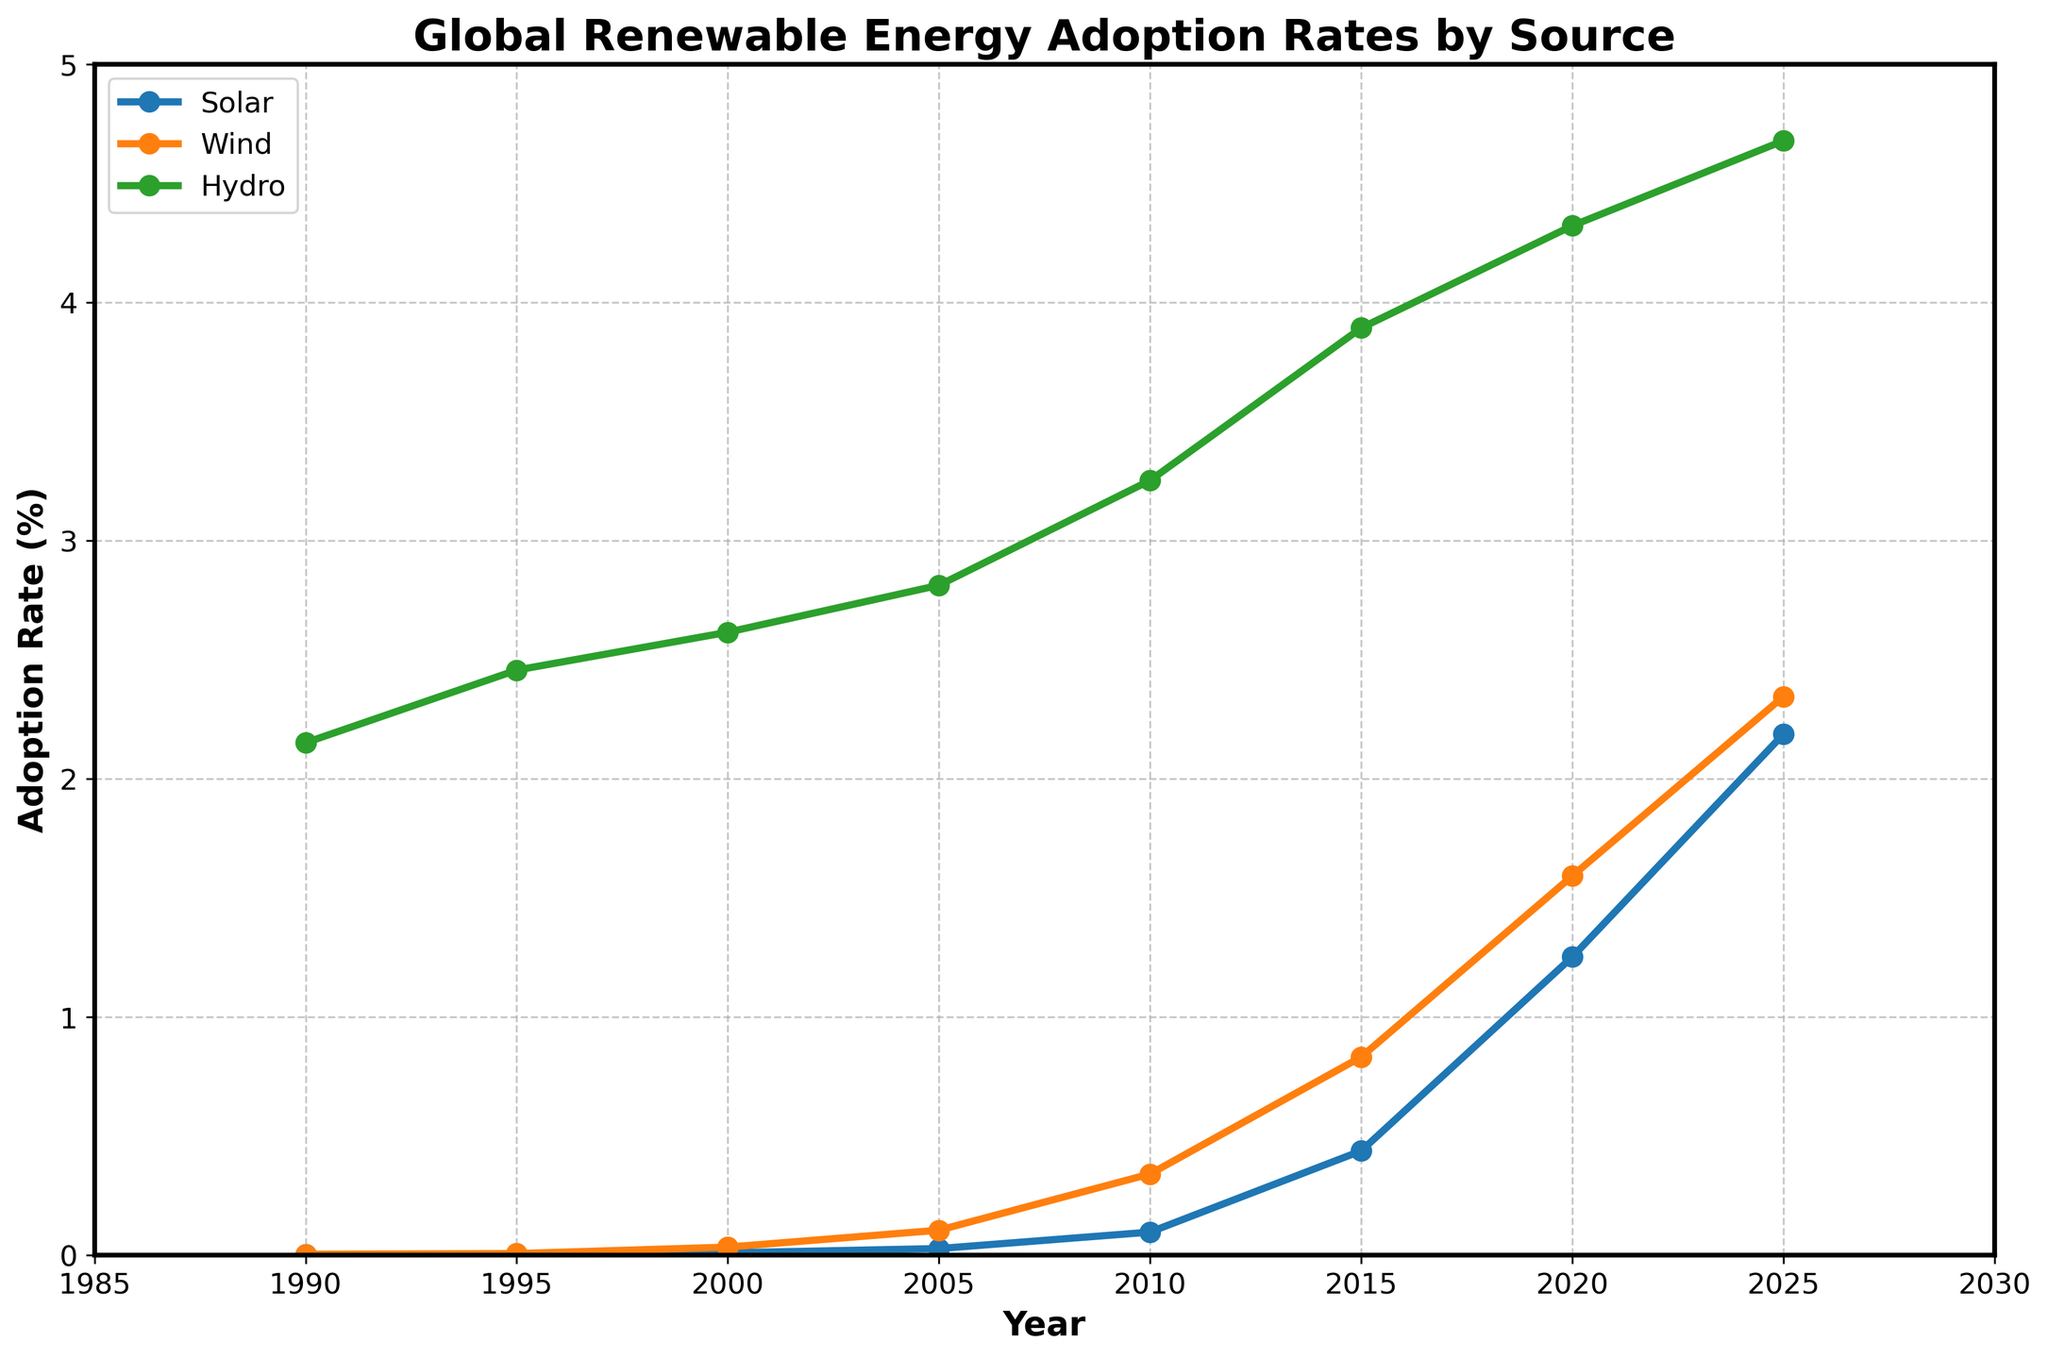What was the Solar adoption rate in 2020? Look at the value of Solar in 2020 on the Y-axis in the chart. Based on the data, the value is 1.252%.
Answer: 1.252% Which renewable energy source had the highest adoption rate in 2010? Compare the adoption rates of Solar, Wind, and Hydro in 2010 on the Y-axis. Hydro has the highest rate at 3.252%.
Answer: Hydro By how much did the Solar adoption rate increase from 2000 to 2005? Subtract the adoption rate of Solar in 2000 (0.010) from that in 2005 (0.028). The increase is 0.028 - 0.010 = 0.018.
Answer: 0.018 In which year did Wind adoption surpass Hydro adoption? Examine the graph where the Wind curve crosses above the Hydro curve. Based on the data, Wind surpasses Hydro around 2025.
Answer: 2025 What is the average adoption rate of Solar from 1990 to 2025? Add all the Solar adoption rates from 1990, 1995, 2000, 2005, 2010, 2015, 2020, and 2025, then divide by the number of data points: (0.002 + 0.004 + 0.010 + 0.028 + 0.097 + 0.438 + 1.252 + 2.187) / 8 = 0.50225.
Answer: 0.50225 Was the rate of adoption growth higher for Solar or Wind between 2015 and 2020? Calculate the increase for Solar between 2015 and 2020 (1.252 - 0.438 = 0.814), and for Wind between 2015 and 2020 (1.592 - 0.832 = 0.76). Compare the two values; the increase is higher for Solar.
Answer: Solar Which energy source shows the steepest increase in adoption rate between any two consecutive time points in the data? Evaluate the steepness of the curve between two consecutive points by calculating the differences. The largest increase in a single jump appears in Solar between 2015 (0.438) and 2020 (1.252), a difference of 0.814.
Answer: Solar By what percentage did the Hydro adoption rate increase from 1990 to 2020? Calculate the difference between the Hydro rates in 1990 (2.151) and 2020 (4.321), then compute the percentage increase: ((4.321 - 2.151) / 2.151) * 100 ≈ 100.91%.
Answer: 100.91% What's the combined adoption rate of Solar and Wind in 2025? Add the Solar and Wind adoption rates in 2025: 2.187 + 2.345 = 4.532.
Answer: 4.532 